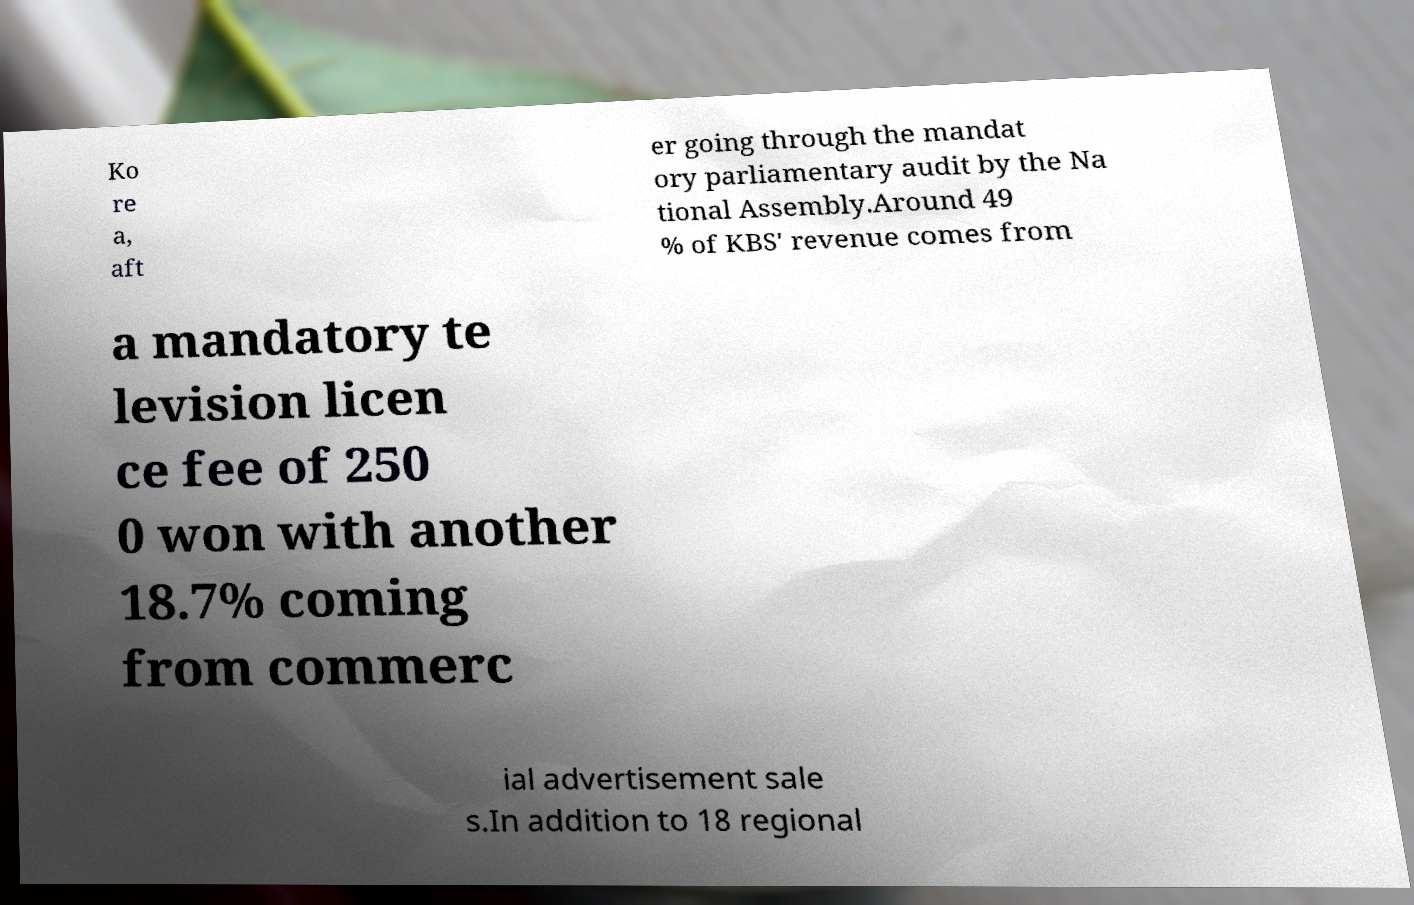Could you extract and type out the text from this image? Ko re a, aft er going through the mandat ory parliamentary audit by the Na tional Assembly.Around 49 % of KBS' revenue comes from a mandatory te levision licen ce fee of 250 0 won with another 18.7% coming from commerc ial advertisement sale s.In addition to 18 regional 